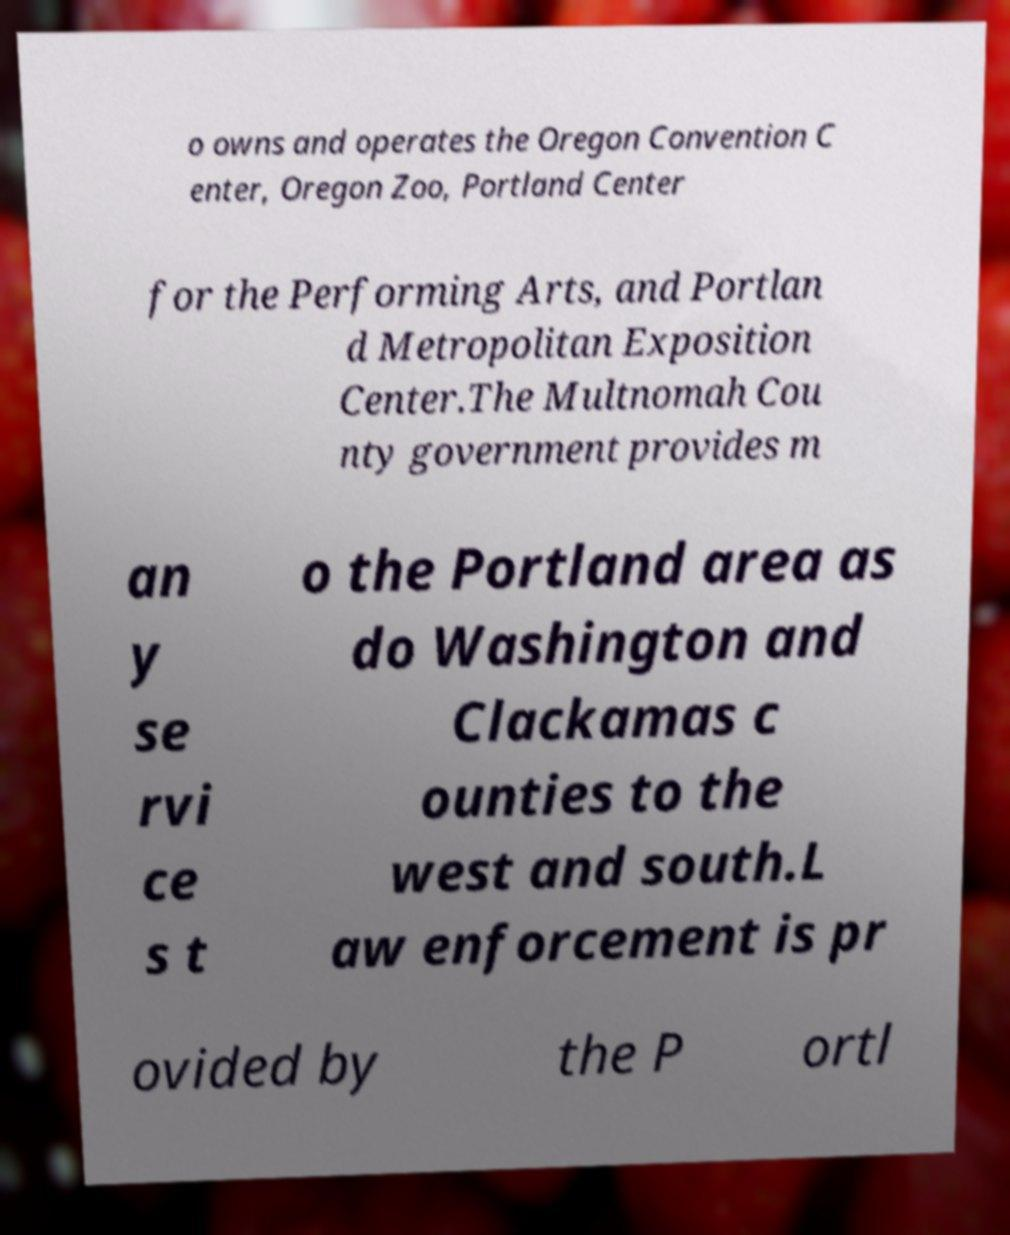Can you read and provide the text displayed in the image?This photo seems to have some interesting text. Can you extract and type it out for me? o owns and operates the Oregon Convention C enter, Oregon Zoo, Portland Center for the Performing Arts, and Portlan d Metropolitan Exposition Center.The Multnomah Cou nty government provides m an y se rvi ce s t o the Portland area as do Washington and Clackamas c ounties to the west and south.L aw enforcement is pr ovided by the P ortl 